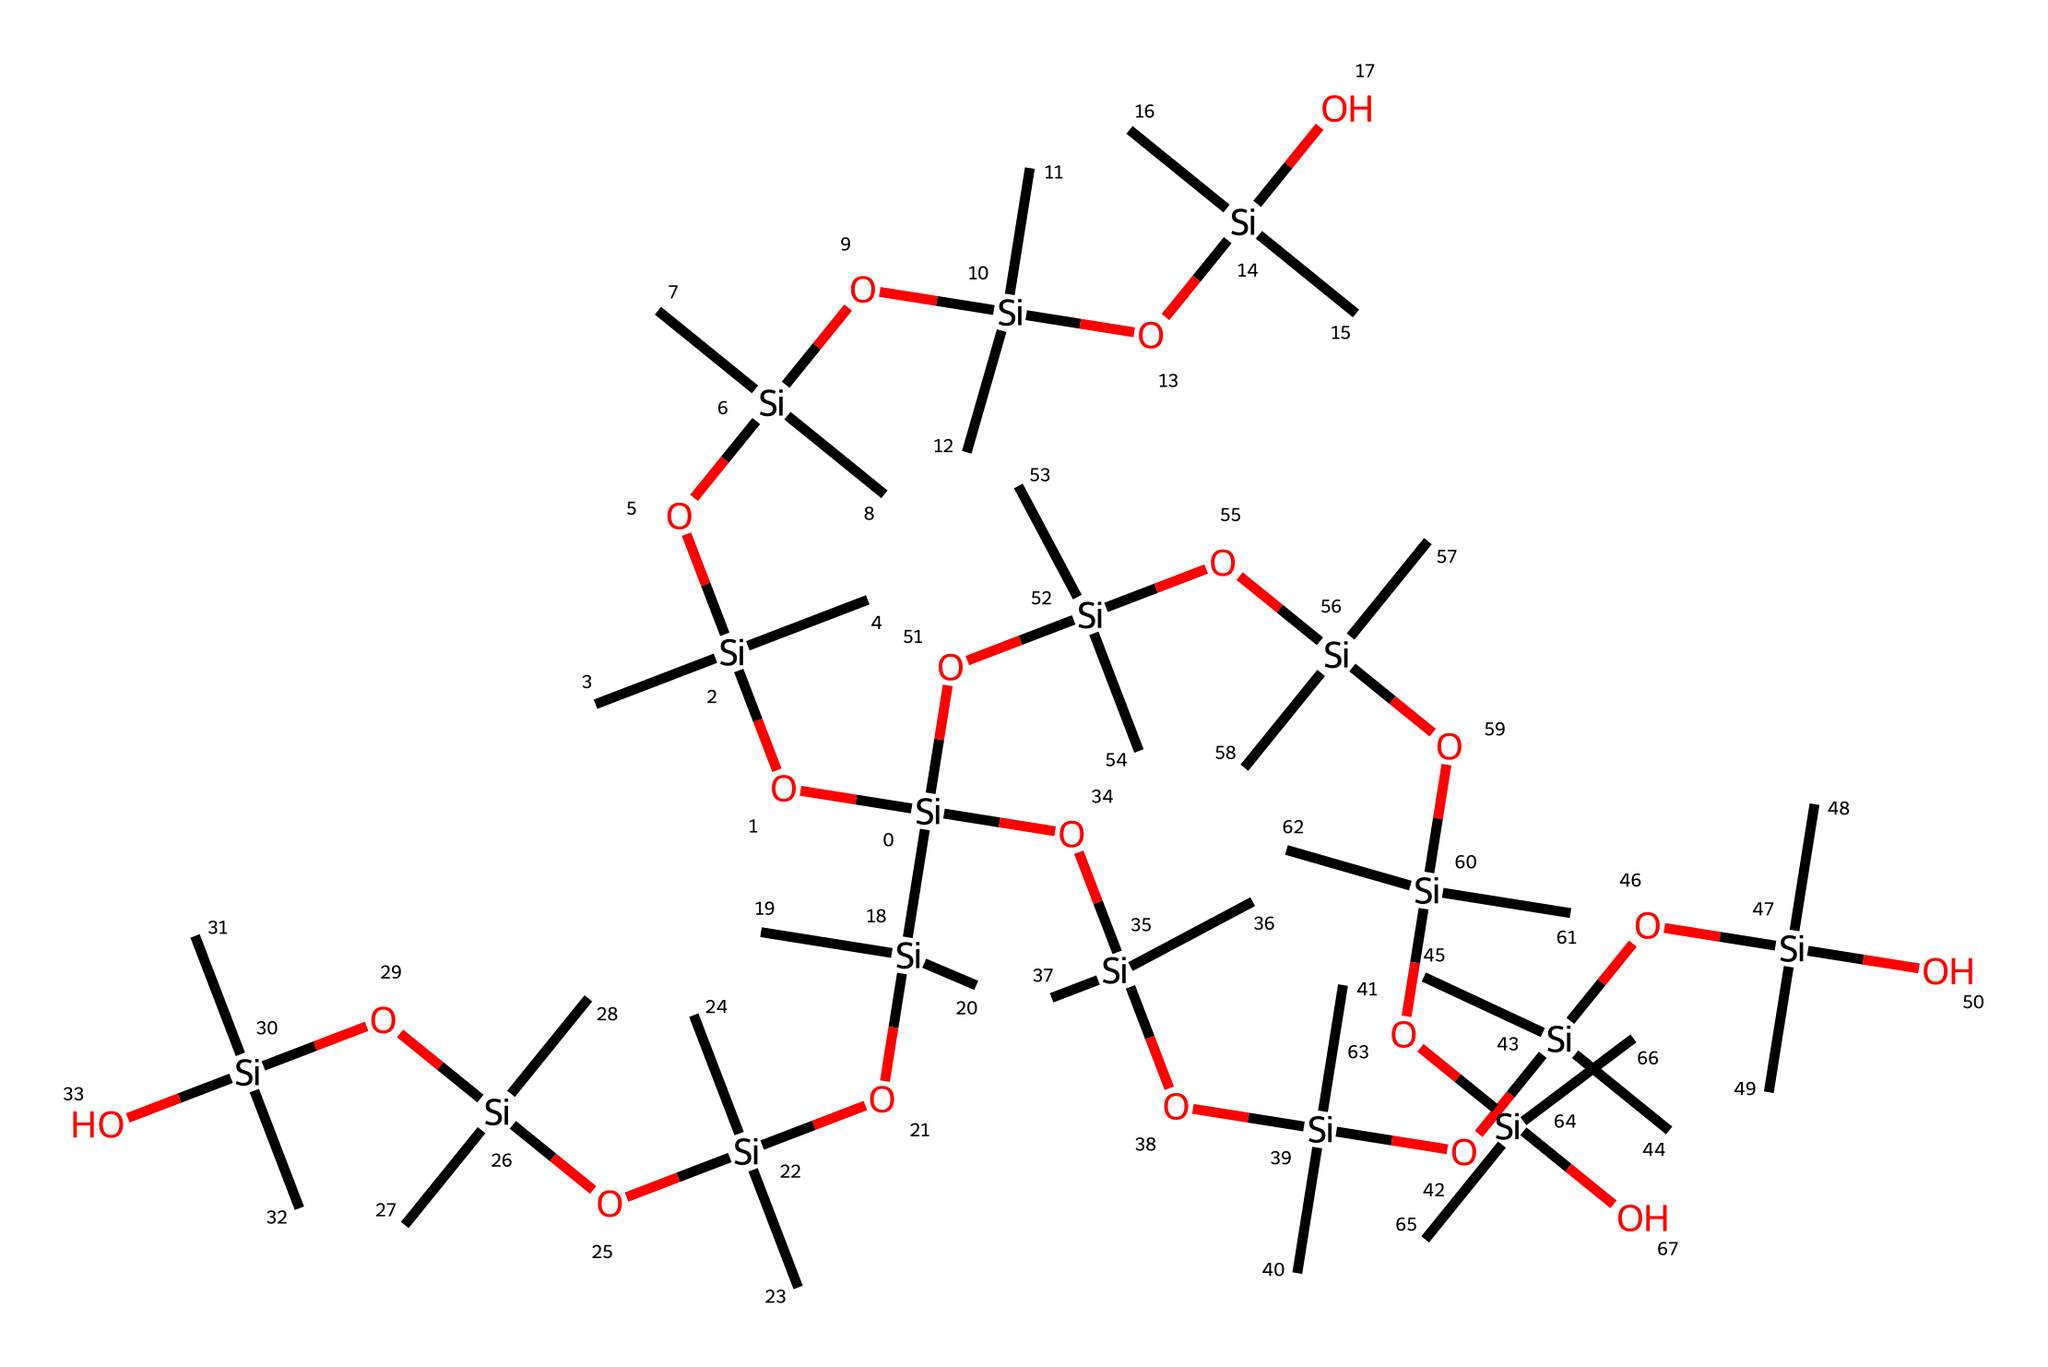What is the primary element in this chemical? The chemical structure shows a central framework of silicon atoms bonded with oxygen and carbon atoms. The presence of silicon is evident from the repeated silicon components in the structure.
Answer: silicon How many silicon atoms are present? By counting the number of 'Si' in the SMILES representation, I note that there are numerous instances, totaling twelve silicon atoms in the structure.
Answer: twelve What type of chemical compound is this? Given that the structure contains silicon-oxygen bonds, along with carbon groups, it is classified as a siloxane compound. This is characteristic of silicone-based materials.
Answer: siloxane How many total silicon-oxygen bonds are in the structure? By examining the connections in the structure, each OH and Si-O bond is a part of the siloxane repeating unit. I count the distinct siloxane linkages to find that there are eleven bonds connecting silicon and oxygen atoms.
Answer: eleven What type of products is this chemical commonly used in? Given that this compound is a silicone polymer with flexible properties, it is commonly found in the manufacture of toys and baby products, which require safety and durability.
Answer: toys and baby products How does the presence of carbon groups affect the properties of this chemical? The carbon groups (indicated by '(C)(C)') contribute to the flexibility and stability of the silicone compound, making it softer and more elastic, which is beneficial for applications like toys that require a safe touch.
Answer: flexibility and stability 